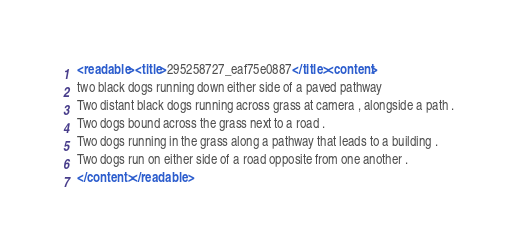<code> <loc_0><loc_0><loc_500><loc_500><_XML_><readable><title>295258727_eaf75e0887</title><content>
two black dogs running down either side of a paved pathway
Two distant black dogs running across grass at camera , alongside a path .
Two dogs bound across the grass next to a road .
Two dogs running in the grass along a pathway that leads to a building .
Two dogs run on either side of a road opposite from one another .
</content></readable></code> 